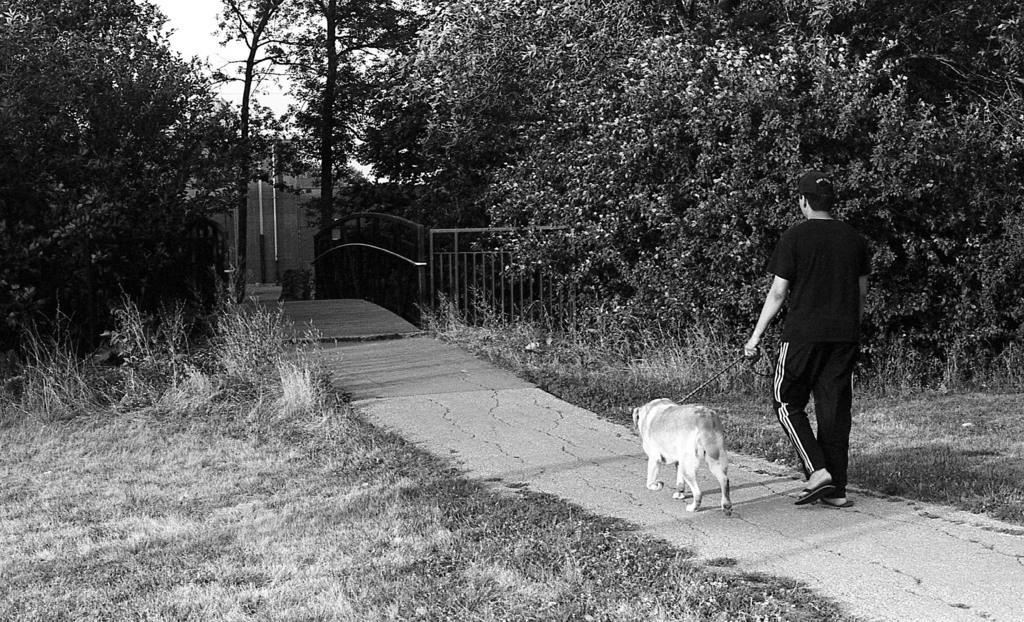What is the main subject of the image? There is a man in the image. What is the man doing in the image? The man is walking in the image. What is the man holding in the image? The man is holding a dog with a string in the image. What can be seen in the background of the image? There are trees visible in the image, and there is a metal fence in the image. What is the man wearing on his head? The man is wearing a cap on his head in the image. What type of pie is the man eating while walking the dog in the image? There is no pie present in the image; the man is holding a dog with a string. How many chickens are visible in the image? There are no chickens visible in the image; the main subjects are the man and the dog. 